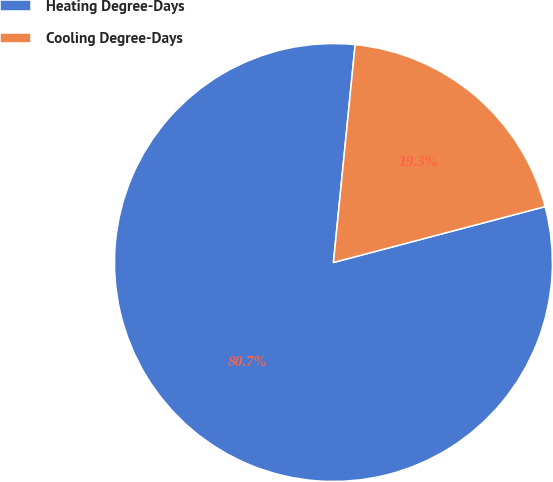<chart> <loc_0><loc_0><loc_500><loc_500><pie_chart><fcel>Heating Degree-Days<fcel>Cooling Degree-Days<nl><fcel>80.69%<fcel>19.31%<nl></chart> 